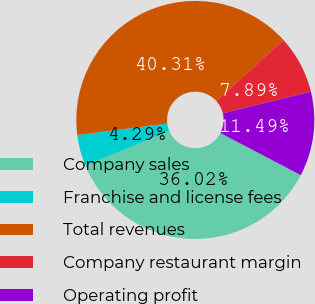Convert chart. <chart><loc_0><loc_0><loc_500><loc_500><pie_chart><fcel>Company sales<fcel>Franchise and license fees<fcel>Total revenues<fcel>Company restaurant margin<fcel>Operating profit<nl><fcel>36.02%<fcel>4.29%<fcel>40.31%<fcel>7.89%<fcel>11.49%<nl></chart> 